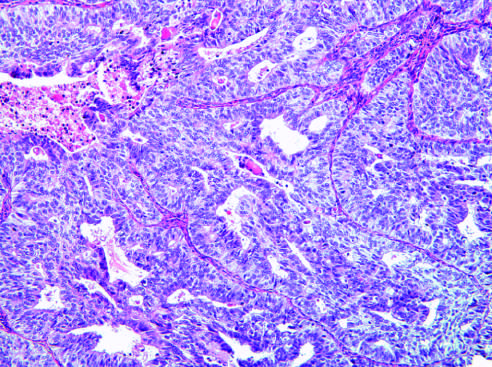does the prominent cell in the center field have a predominantly solid growth pattern?
Answer the question using a single word or phrase. No 